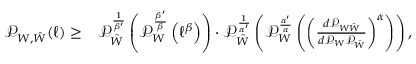Convert formula to latex. <formula><loc_0><loc_0><loc_500><loc_500>\begin{array} { r l } { \mathcal { P } _ { W , \hat { W } } ( \ell ) \geq } & { \mathcal { P } _ { \hat { W } } ^ { \frac { 1 } { \beta ^ { \prime } } } \left ( \mathcal { P } _ { W } ^ { \frac { \beta ^ { \prime } } { \beta } } \left ( \ell ^ { \beta } \right ) \right ) \cdot \mathcal { P } _ { \hat { W } } ^ { \frac { 1 } { \alpha ^ { \prime } } } \left ( \mathcal { P } _ { W } ^ { \frac { \alpha ^ { \prime } } { \alpha } } \left ( \left ( \frac { d \mathcal { P } _ { W \hat { W } } } { d \mathcal { P } _ { W } \mathcal { P } _ { \hat { W } } } \right ) ^ { \alpha } \right ) \right ) , } \end{array}</formula> 